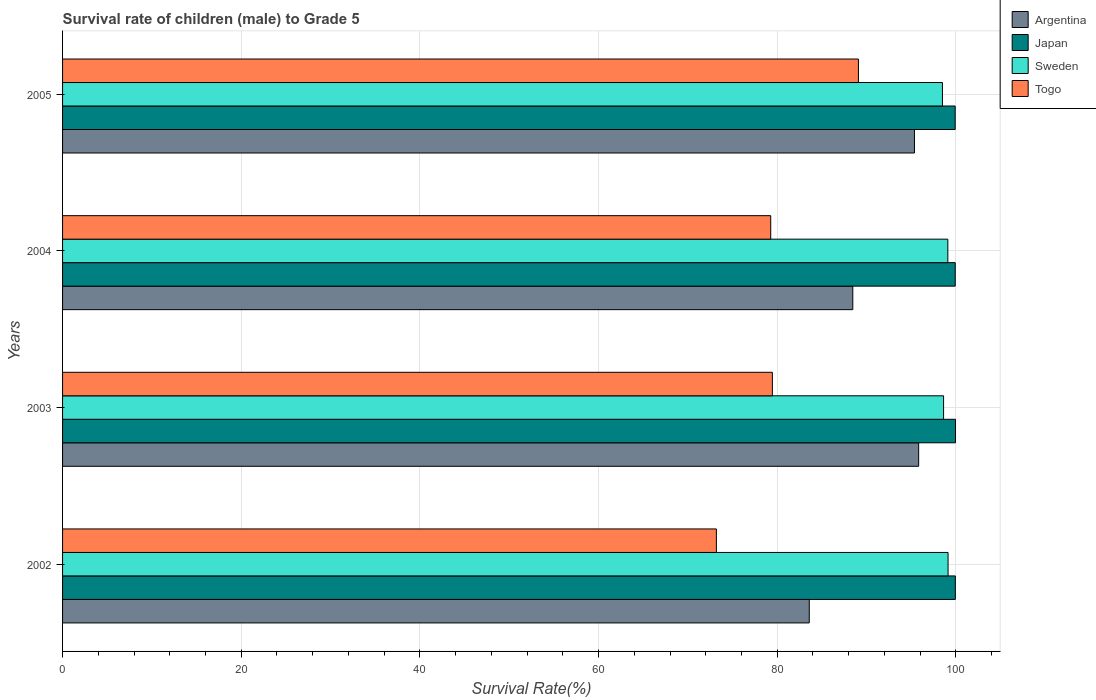How many different coloured bars are there?
Ensure brevity in your answer.  4. How many bars are there on the 3rd tick from the top?
Offer a terse response. 4. What is the label of the 1st group of bars from the top?
Provide a short and direct response. 2005. What is the survival rate of male children to grade 5 in Argentina in 2003?
Provide a short and direct response. 95.84. Across all years, what is the maximum survival rate of male children to grade 5 in Sweden?
Offer a terse response. 99.13. Across all years, what is the minimum survival rate of male children to grade 5 in Argentina?
Your answer should be compact. 83.59. What is the total survival rate of male children to grade 5 in Sweden in the graph?
Your answer should be compact. 395.36. What is the difference between the survival rate of male children to grade 5 in Sweden in 2003 and that in 2004?
Provide a short and direct response. -0.48. What is the difference between the survival rate of male children to grade 5 in Sweden in 2005 and the survival rate of male children to grade 5 in Argentina in 2003?
Make the answer very short. 2.66. What is the average survival rate of male children to grade 5 in Japan per year?
Offer a very short reply. 99.94. In the year 2003, what is the difference between the survival rate of male children to grade 5 in Sweden and survival rate of male children to grade 5 in Japan?
Make the answer very short. -1.34. What is the ratio of the survival rate of male children to grade 5 in Sweden in 2003 to that in 2005?
Your answer should be very brief. 1. Is the survival rate of male children to grade 5 in Sweden in 2003 less than that in 2004?
Ensure brevity in your answer.  Yes. Is the difference between the survival rate of male children to grade 5 in Sweden in 2002 and 2004 greater than the difference between the survival rate of male children to grade 5 in Japan in 2002 and 2004?
Your answer should be compact. Yes. What is the difference between the highest and the second highest survival rate of male children to grade 5 in Japan?
Give a very brief answer. 0.02. What is the difference between the highest and the lowest survival rate of male children to grade 5 in Argentina?
Offer a terse response. 12.25. Is it the case that in every year, the sum of the survival rate of male children to grade 5 in Argentina and survival rate of male children to grade 5 in Sweden is greater than the sum of survival rate of male children to grade 5 in Togo and survival rate of male children to grade 5 in Japan?
Provide a succinct answer. No. What does the 3rd bar from the top in 2003 represents?
Your answer should be very brief. Japan. What does the 2nd bar from the bottom in 2003 represents?
Your answer should be very brief. Japan. What is the difference between two consecutive major ticks on the X-axis?
Your response must be concise. 20. Does the graph contain any zero values?
Your response must be concise. No. Where does the legend appear in the graph?
Provide a succinct answer. Top right. How are the legend labels stacked?
Your answer should be compact. Vertical. What is the title of the graph?
Your answer should be very brief. Survival rate of children (male) to Grade 5. What is the label or title of the X-axis?
Your response must be concise. Survival Rate(%). What is the label or title of the Y-axis?
Ensure brevity in your answer.  Years. What is the Survival Rate(%) in Argentina in 2002?
Provide a short and direct response. 83.59. What is the Survival Rate(%) in Japan in 2002?
Provide a succinct answer. 99.94. What is the Survival Rate(%) in Sweden in 2002?
Provide a succinct answer. 99.13. What is the Survival Rate(%) of Togo in 2002?
Your answer should be very brief. 73.19. What is the Survival Rate(%) of Argentina in 2003?
Your answer should be very brief. 95.84. What is the Survival Rate(%) in Japan in 2003?
Your answer should be compact. 99.96. What is the Survival Rate(%) of Sweden in 2003?
Keep it short and to the point. 98.63. What is the Survival Rate(%) in Togo in 2003?
Provide a short and direct response. 79.46. What is the Survival Rate(%) in Argentina in 2004?
Provide a succinct answer. 88.46. What is the Survival Rate(%) in Japan in 2004?
Offer a very short reply. 99.93. What is the Survival Rate(%) of Sweden in 2004?
Provide a succinct answer. 99.1. What is the Survival Rate(%) in Togo in 2004?
Make the answer very short. 79.28. What is the Survival Rate(%) of Argentina in 2005?
Your answer should be compact. 95.37. What is the Survival Rate(%) in Japan in 2005?
Give a very brief answer. 99.93. What is the Survival Rate(%) of Sweden in 2005?
Offer a very short reply. 98.5. What is the Survival Rate(%) in Togo in 2005?
Keep it short and to the point. 89.09. Across all years, what is the maximum Survival Rate(%) of Argentina?
Your response must be concise. 95.84. Across all years, what is the maximum Survival Rate(%) in Japan?
Your answer should be very brief. 99.96. Across all years, what is the maximum Survival Rate(%) in Sweden?
Provide a succinct answer. 99.13. Across all years, what is the maximum Survival Rate(%) of Togo?
Keep it short and to the point. 89.09. Across all years, what is the minimum Survival Rate(%) of Argentina?
Offer a terse response. 83.59. Across all years, what is the minimum Survival Rate(%) of Japan?
Give a very brief answer. 99.93. Across all years, what is the minimum Survival Rate(%) in Sweden?
Offer a very short reply. 98.5. Across all years, what is the minimum Survival Rate(%) in Togo?
Give a very brief answer. 73.19. What is the total Survival Rate(%) in Argentina in the graph?
Make the answer very short. 363.26. What is the total Survival Rate(%) of Japan in the graph?
Give a very brief answer. 399.76. What is the total Survival Rate(%) of Sweden in the graph?
Keep it short and to the point. 395.36. What is the total Survival Rate(%) of Togo in the graph?
Provide a short and direct response. 321.02. What is the difference between the Survival Rate(%) of Argentina in 2002 and that in 2003?
Provide a short and direct response. -12.25. What is the difference between the Survival Rate(%) of Japan in 2002 and that in 2003?
Provide a short and direct response. -0.02. What is the difference between the Survival Rate(%) of Sweden in 2002 and that in 2003?
Ensure brevity in your answer.  0.5. What is the difference between the Survival Rate(%) of Togo in 2002 and that in 2003?
Give a very brief answer. -6.27. What is the difference between the Survival Rate(%) in Argentina in 2002 and that in 2004?
Provide a succinct answer. -4.87. What is the difference between the Survival Rate(%) in Japan in 2002 and that in 2004?
Offer a very short reply. 0.01. What is the difference between the Survival Rate(%) of Sweden in 2002 and that in 2004?
Offer a terse response. 0.03. What is the difference between the Survival Rate(%) of Togo in 2002 and that in 2004?
Provide a short and direct response. -6.08. What is the difference between the Survival Rate(%) in Argentina in 2002 and that in 2005?
Provide a succinct answer. -11.78. What is the difference between the Survival Rate(%) of Japan in 2002 and that in 2005?
Ensure brevity in your answer.  0.02. What is the difference between the Survival Rate(%) of Sweden in 2002 and that in 2005?
Your answer should be very brief. 0.63. What is the difference between the Survival Rate(%) of Togo in 2002 and that in 2005?
Offer a terse response. -15.9. What is the difference between the Survival Rate(%) in Argentina in 2003 and that in 2004?
Provide a short and direct response. 7.37. What is the difference between the Survival Rate(%) of Japan in 2003 and that in 2004?
Give a very brief answer. 0.03. What is the difference between the Survival Rate(%) in Sweden in 2003 and that in 2004?
Make the answer very short. -0.48. What is the difference between the Survival Rate(%) in Togo in 2003 and that in 2004?
Make the answer very short. 0.18. What is the difference between the Survival Rate(%) in Argentina in 2003 and that in 2005?
Your response must be concise. 0.47. What is the difference between the Survival Rate(%) in Japan in 2003 and that in 2005?
Make the answer very short. 0.04. What is the difference between the Survival Rate(%) in Sweden in 2003 and that in 2005?
Keep it short and to the point. 0.13. What is the difference between the Survival Rate(%) of Togo in 2003 and that in 2005?
Provide a succinct answer. -9.63. What is the difference between the Survival Rate(%) in Argentina in 2004 and that in 2005?
Your answer should be compact. -6.9. What is the difference between the Survival Rate(%) in Japan in 2004 and that in 2005?
Ensure brevity in your answer.  0. What is the difference between the Survival Rate(%) of Sweden in 2004 and that in 2005?
Provide a short and direct response. 0.6. What is the difference between the Survival Rate(%) in Togo in 2004 and that in 2005?
Offer a very short reply. -9.82. What is the difference between the Survival Rate(%) of Argentina in 2002 and the Survival Rate(%) of Japan in 2003?
Offer a very short reply. -16.37. What is the difference between the Survival Rate(%) of Argentina in 2002 and the Survival Rate(%) of Sweden in 2003?
Ensure brevity in your answer.  -15.04. What is the difference between the Survival Rate(%) of Argentina in 2002 and the Survival Rate(%) of Togo in 2003?
Offer a terse response. 4.13. What is the difference between the Survival Rate(%) in Japan in 2002 and the Survival Rate(%) in Sweden in 2003?
Offer a very short reply. 1.32. What is the difference between the Survival Rate(%) of Japan in 2002 and the Survival Rate(%) of Togo in 2003?
Your answer should be very brief. 20.48. What is the difference between the Survival Rate(%) in Sweden in 2002 and the Survival Rate(%) in Togo in 2003?
Offer a very short reply. 19.67. What is the difference between the Survival Rate(%) in Argentina in 2002 and the Survival Rate(%) in Japan in 2004?
Make the answer very short. -16.34. What is the difference between the Survival Rate(%) of Argentina in 2002 and the Survival Rate(%) of Sweden in 2004?
Make the answer very short. -15.51. What is the difference between the Survival Rate(%) of Argentina in 2002 and the Survival Rate(%) of Togo in 2004?
Your answer should be very brief. 4.32. What is the difference between the Survival Rate(%) in Japan in 2002 and the Survival Rate(%) in Sweden in 2004?
Give a very brief answer. 0.84. What is the difference between the Survival Rate(%) of Japan in 2002 and the Survival Rate(%) of Togo in 2004?
Provide a short and direct response. 20.67. What is the difference between the Survival Rate(%) in Sweden in 2002 and the Survival Rate(%) in Togo in 2004?
Your answer should be compact. 19.85. What is the difference between the Survival Rate(%) of Argentina in 2002 and the Survival Rate(%) of Japan in 2005?
Provide a succinct answer. -16.34. What is the difference between the Survival Rate(%) in Argentina in 2002 and the Survival Rate(%) in Sweden in 2005?
Ensure brevity in your answer.  -14.91. What is the difference between the Survival Rate(%) of Argentina in 2002 and the Survival Rate(%) of Togo in 2005?
Your answer should be very brief. -5.5. What is the difference between the Survival Rate(%) in Japan in 2002 and the Survival Rate(%) in Sweden in 2005?
Provide a succinct answer. 1.44. What is the difference between the Survival Rate(%) of Japan in 2002 and the Survival Rate(%) of Togo in 2005?
Provide a short and direct response. 10.85. What is the difference between the Survival Rate(%) in Sweden in 2002 and the Survival Rate(%) in Togo in 2005?
Your answer should be very brief. 10.03. What is the difference between the Survival Rate(%) in Argentina in 2003 and the Survival Rate(%) in Japan in 2004?
Give a very brief answer. -4.09. What is the difference between the Survival Rate(%) of Argentina in 2003 and the Survival Rate(%) of Sweden in 2004?
Your response must be concise. -3.27. What is the difference between the Survival Rate(%) in Argentina in 2003 and the Survival Rate(%) in Togo in 2004?
Provide a succinct answer. 16.56. What is the difference between the Survival Rate(%) of Japan in 2003 and the Survival Rate(%) of Sweden in 2004?
Your response must be concise. 0.86. What is the difference between the Survival Rate(%) in Japan in 2003 and the Survival Rate(%) in Togo in 2004?
Make the answer very short. 20.69. What is the difference between the Survival Rate(%) of Sweden in 2003 and the Survival Rate(%) of Togo in 2004?
Keep it short and to the point. 19.35. What is the difference between the Survival Rate(%) of Argentina in 2003 and the Survival Rate(%) of Japan in 2005?
Provide a short and direct response. -4.09. What is the difference between the Survival Rate(%) in Argentina in 2003 and the Survival Rate(%) in Sweden in 2005?
Provide a short and direct response. -2.66. What is the difference between the Survival Rate(%) of Argentina in 2003 and the Survival Rate(%) of Togo in 2005?
Ensure brevity in your answer.  6.74. What is the difference between the Survival Rate(%) in Japan in 2003 and the Survival Rate(%) in Sweden in 2005?
Make the answer very short. 1.46. What is the difference between the Survival Rate(%) of Japan in 2003 and the Survival Rate(%) of Togo in 2005?
Offer a very short reply. 10.87. What is the difference between the Survival Rate(%) of Sweden in 2003 and the Survival Rate(%) of Togo in 2005?
Your answer should be very brief. 9.53. What is the difference between the Survival Rate(%) in Argentina in 2004 and the Survival Rate(%) in Japan in 2005?
Your response must be concise. -11.46. What is the difference between the Survival Rate(%) of Argentina in 2004 and the Survival Rate(%) of Sweden in 2005?
Make the answer very short. -10.04. What is the difference between the Survival Rate(%) in Argentina in 2004 and the Survival Rate(%) in Togo in 2005?
Give a very brief answer. -0.63. What is the difference between the Survival Rate(%) in Japan in 2004 and the Survival Rate(%) in Sweden in 2005?
Provide a succinct answer. 1.43. What is the difference between the Survival Rate(%) of Japan in 2004 and the Survival Rate(%) of Togo in 2005?
Your response must be concise. 10.84. What is the difference between the Survival Rate(%) in Sweden in 2004 and the Survival Rate(%) in Togo in 2005?
Offer a terse response. 10.01. What is the average Survival Rate(%) of Argentina per year?
Your answer should be very brief. 90.81. What is the average Survival Rate(%) of Japan per year?
Make the answer very short. 99.94. What is the average Survival Rate(%) in Sweden per year?
Offer a very short reply. 98.84. What is the average Survival Rate(%) of Togo per year?
Provide a short and direct response. 80.26. In the year 2002, what is the difference between the Survival Rate(%) of Argentina and Survival Rate(%) of Japan?
Make the answer very short. -16.35. In the year 2002, what is the difference between the Survival Rate(%) in Argentina and Survival Rate(%) in Sweden?
Your response must be concise. -15.54. In the year 2002, what is the difference between the Survival Rate(%) in Argentina and Survival Rate(%) in Togo?
Your answer should be very brief. 10.4. In the year 2002, what is the difference between the Survival Rate(%) in Japan and Survival Rate(%) in Sweden?
Keep it short and to the point. 0.82. In the year 2002, what is the difference between the Survival Rate(%) of Japan and Survival Rate(%) of Togo?
Keep it short and to the point. 26.75. In the year 2002, what is the difference between the Survival Rate(%) of Sweden and Survival Rate(%) of Togo?
Your answer should be very brief. 25.93. In the year 2003, what is the difference between the Survival Rate(%) of Argentina and Survival Rate(%) of Japan?
Offer a very short reply. -4.13. In the year 2003, what is the difference between the Survival Rate(%) of Argentina and Survival Rate(%) of Sweden?
Your answer should be very brief. -2.79. In the year 2003, what is the difference between the Survival Rate(%) of Argentina and Survival Rate(%) of Togo?
Ensure brevity in your answer.  16.38. In the year 2003, what is the difference between the Survival Rate(%) of Japan and Survival Rate(%) of Sweden?
Ensure brevity in your answer.  1.34. In the year 2003, what is the difference between the Survival Rate(%) in Japan and Survival Rate(%) in Togo?
Offer a terse response. 20.5. In the year 2003, what is the difference between the Survival Rate(%) of Sweden and Survival Rate(%) of Togo?
Your response must be concise. 19.17. In the year 2004, what is the difference between the Survival Rate(%) in Argentina and Survival Rate(%) in Japan?
Your response must be concise. -11.47. In the year 2004, what is the difference between the Survival Rate(%) of Argentina and Survival Rate(%) of Sweden?
Provide a succinct answer. -10.64. In the year 2004, what is the difference between the Survival Rate(%) of Argentina and Survival Rate(%) of Togo?
Keep it short and to the point. 9.19. In the year 2004, what is the difference between the Survival Rate(%) of Japan and Survival Rate(%) of Sweden?
Offer a very short reply. 0.83. In the year 2004, what is the difference between the Survival Rate(%) of Japan and Survival Rate(%) of Togo?
Offer a terse response. 20.66. In the year 2004, what is the difference between the Survival Rate(%) of Sweden and Survival Rate(%) of Togo?
Your response must be concise. 19.83. In the year 2005, what is the difference between the Survival Rate(%) of Argentina and Survival Rate(%) of Japan?
Give a very brief answer. -4.56. In the year 2005, what is the difference between the Survival Rate(%) in Argentina and Survival Rate(%) in Sweden?
Your response must be concise. -3.13. In the year 2005, what is the difference between the Survival Rate(%) in Argentina and Survival Rate(%) in Togo?
Provide a succinct answer. 6.27. In the year 2005, what is the difference between the Survival Rate(%) in Japan and Survival Rate(%) in Sweden?
Provide a short and direct response. 1.43. In the year 2005, what is the difference between the Survival Rate(%) in Japan and Survival Rate(%) in Togo?
Offer a very short reply. 10.83. In the year 2005, what is the difference between the Survival Rate(%) of Sweden and Survival Rate(%) of Togo?
Offer a terse response. 9.41. What is the ratio of the Survival Rate(%) in Argentina in 2002 to that in 2003?
Give a very brief answer. 0.87. What is the ratio of the Survival Rate(%) of Sweden in 2002 to that in 2003?
Keep it short and to the point. 1.01. What is the ratio of the Survival Rate(%) of Togo in 2002 to that in 2003?
Your answer should be very brief. 0.92. What is the ratio of the Survival Rate(%) of Argentina in 2002 to that in 2004?
Your answer should be very brief. 0.94. What is the ratio of the Survival Rate(%) of Japan in 2002 to that in 2004?
Provide a short and direct response. 1. What is the ratio of the Survival Rate(%) of Sweden in 2002 to that in 2004?
Offer a very short reply. 1. What is the ratio of the Survival Rate(%) of Togo in 2002 to that in 2004?
Give a very brief answer. 0.92. What is the ratio of the Survival Rate(%) of Argentina in 2002 to that in 2005?
Offer a very short reply. 0.88. What is the ratio of the Survival Rate(%) of Japan in 2002 to that in 2005?
Make the answer very short. 1. What is the ratio of the Survival Rate(%) in Sweden in 2002 to that in 2005?
Keep it short and to the point. 1.01. What is the ratio of the Survival Rate(%) in Togo in 2002 to that in 2005?
Give a very brief answer. 0.82. What is the ratio of the Survival Rate(%) in Argentina in 2003 to that in 2004?
Provide a short and direct response. 1.08. What is the ratio of the Survival Rate(%) in Argentina in 2003 to that in 2005?
Offer a terse response. 1. What is the ratio of the Survival Rate(%) in Japan in 2003 to that in 2005?
Your answer should be very brief. 1. What is the ratio of the Survival Rate(%) of Togo in 2003 to that in 2005?
Make the answer very short. 0.89. What is the ratio of the Survival Rate(%) in Argentina in 2004 to that in 2005?
Provide a succinct answer. 0.93. What is the ratio of the Survival Rate(%) in Sweden in 2004 to that in 2005?
Your answer should be very brief. 1.01. What is the ratio of the Survival Rate(%) of Togo in 2004 to that in 2005?
Offer a terse response. 0.89. What is the difference between the highest and the second highest Survival Rate(%) in Argentina?
Give a very brief answer. 0.47. What is the difference between the highest and the second highest Survival Rate(%) in Japan?
Provide a succinct answer. 0.02. What is the difference between the highest and the second highest Survival Rate(%) in Sweden?
Make the answer very short. 0.03. What is the difference between the highest and the second highest Survival Rate(%) of Togo?
Provide a short and direct response. 9.63. What is the difference between the highest and the lowest Survival Rate(%) in Argentina?
Your answer should be compact. 12.25. What is the difference between the highest and the lowest Survival Rate(%) in Japan?
Your response must be concise. 0.04. What is the difference between the highest and the lowest Survival Rate(%) of Sweden?
Offer a very short reply. 0.63. What is the difference between the highest and the lowest Survival Rate(%) in Togo?
Provide a short and direct response. 15.9. 